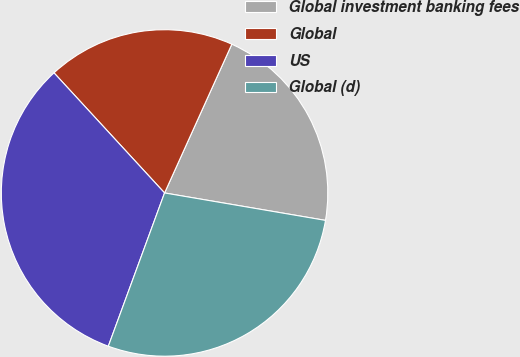Convert chart to OTSL. <chart><loc_0><loc_0><loc_500><loc_500><pie_chart><fcel>Global investment banking fees<fcel>Global<fcel>US<fcel>Global (d)<nl><fcel>20.93%<fcel>18.6%<fcel>32.56%<fcel>27.91%<nl></chart> 